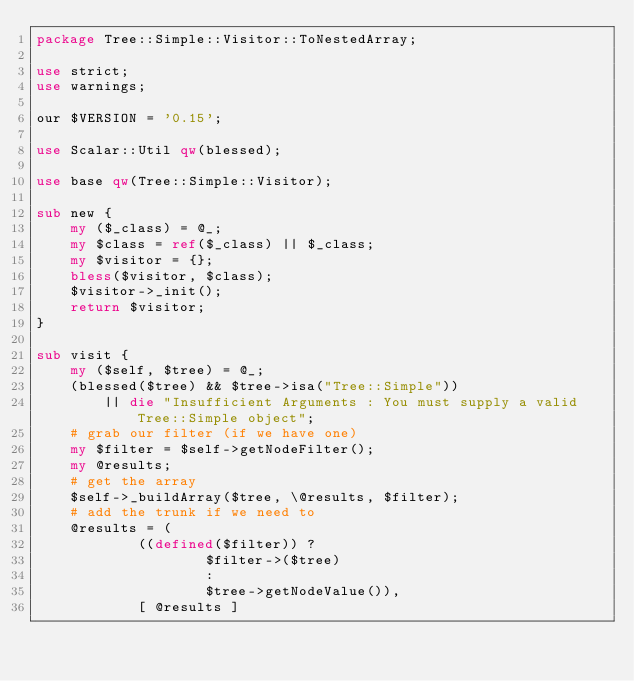Convert code to text. <code><loc_0><loc_0><loc_500><loc_500><_Perl_>package Tree::Simple::Visitor::ToNestedArray;

use strict;
use warnings;

our $VERSION = '0.15';

use Scalar::Util qw(blessed);

use base qw(Tree::Simple::Visitor);

sub new {
    my ($_class) = @_;
    my $class = ref($_class) || $_class;
    my $visitor = {};
    bless($visitor, $class);
    $visitor->_init();
    return $visitor;
}

sub visit {
	my ($self, $tree) = @_;
	(blessed($tree) && $tree->isa("Tree::Simple"))
		|| die "Insufficient Arguments : You must supply a valid Tree::Simple object";
    # grab our filter (if we have one)
    my $filter = $self->getNodeFilter();
    my @results;
    # get the array
    $self->_buildArray($tree, \@results, $filter);
    # add the trunk if we need to
    @results = (
            ((defined($filter)) ?
                    $filter->($tree)
                    :
                    $tree->getNodeValue()),
            [ @results ]</code> 